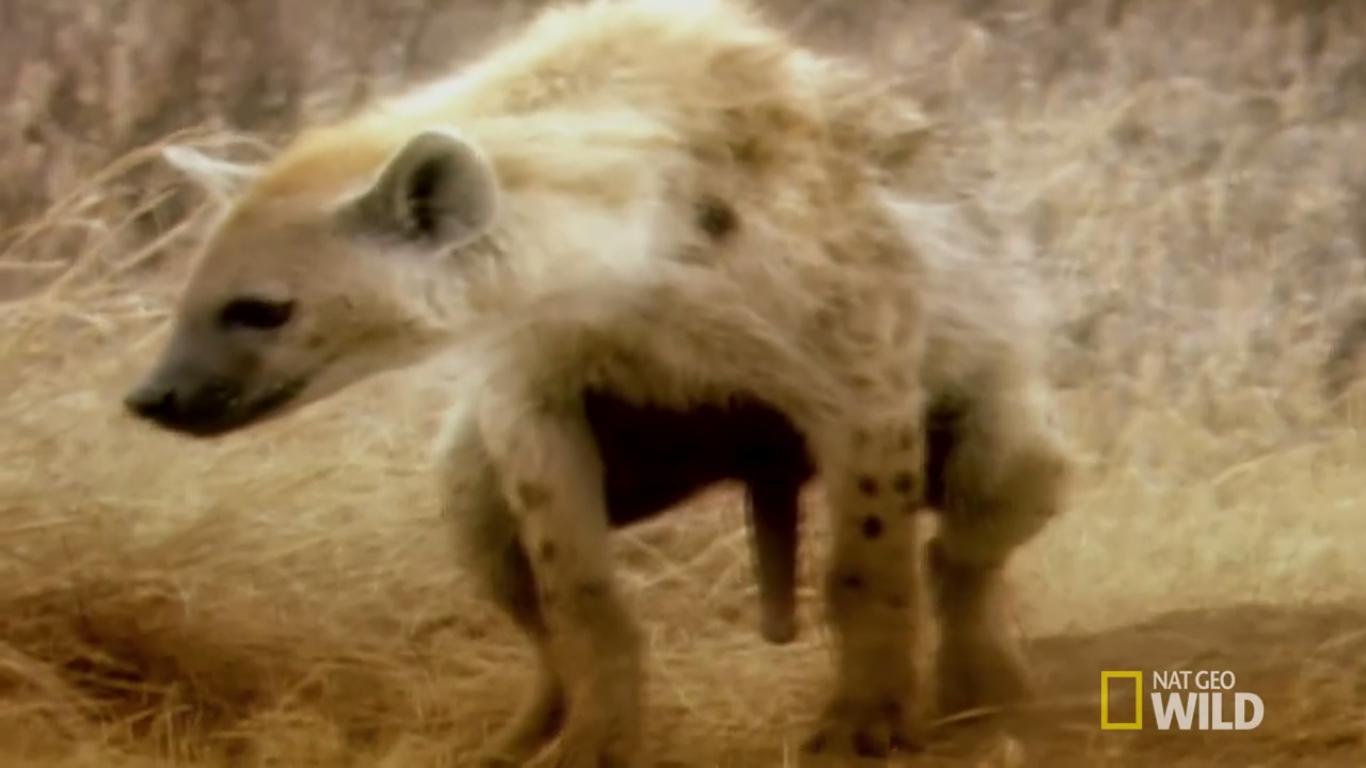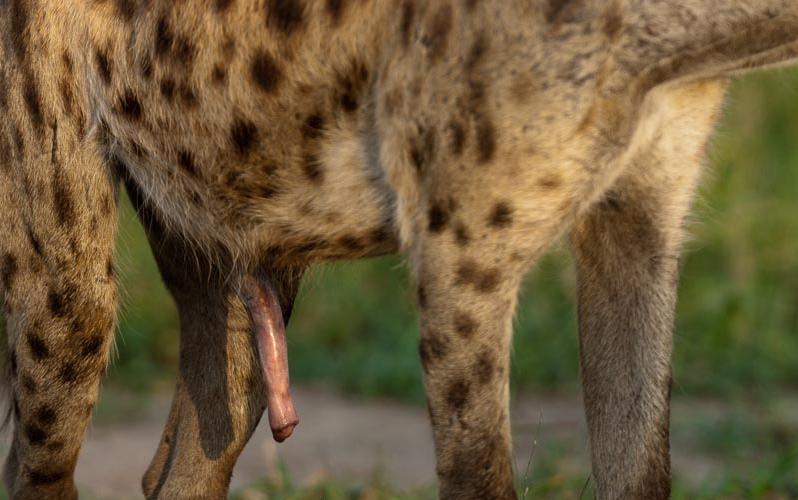The first image is the image on the left, the second image is the image on the right. For the images displayed, is the sentence "There are exactly two animals in the image on the left." factually correct? Answer yes or no. No. 